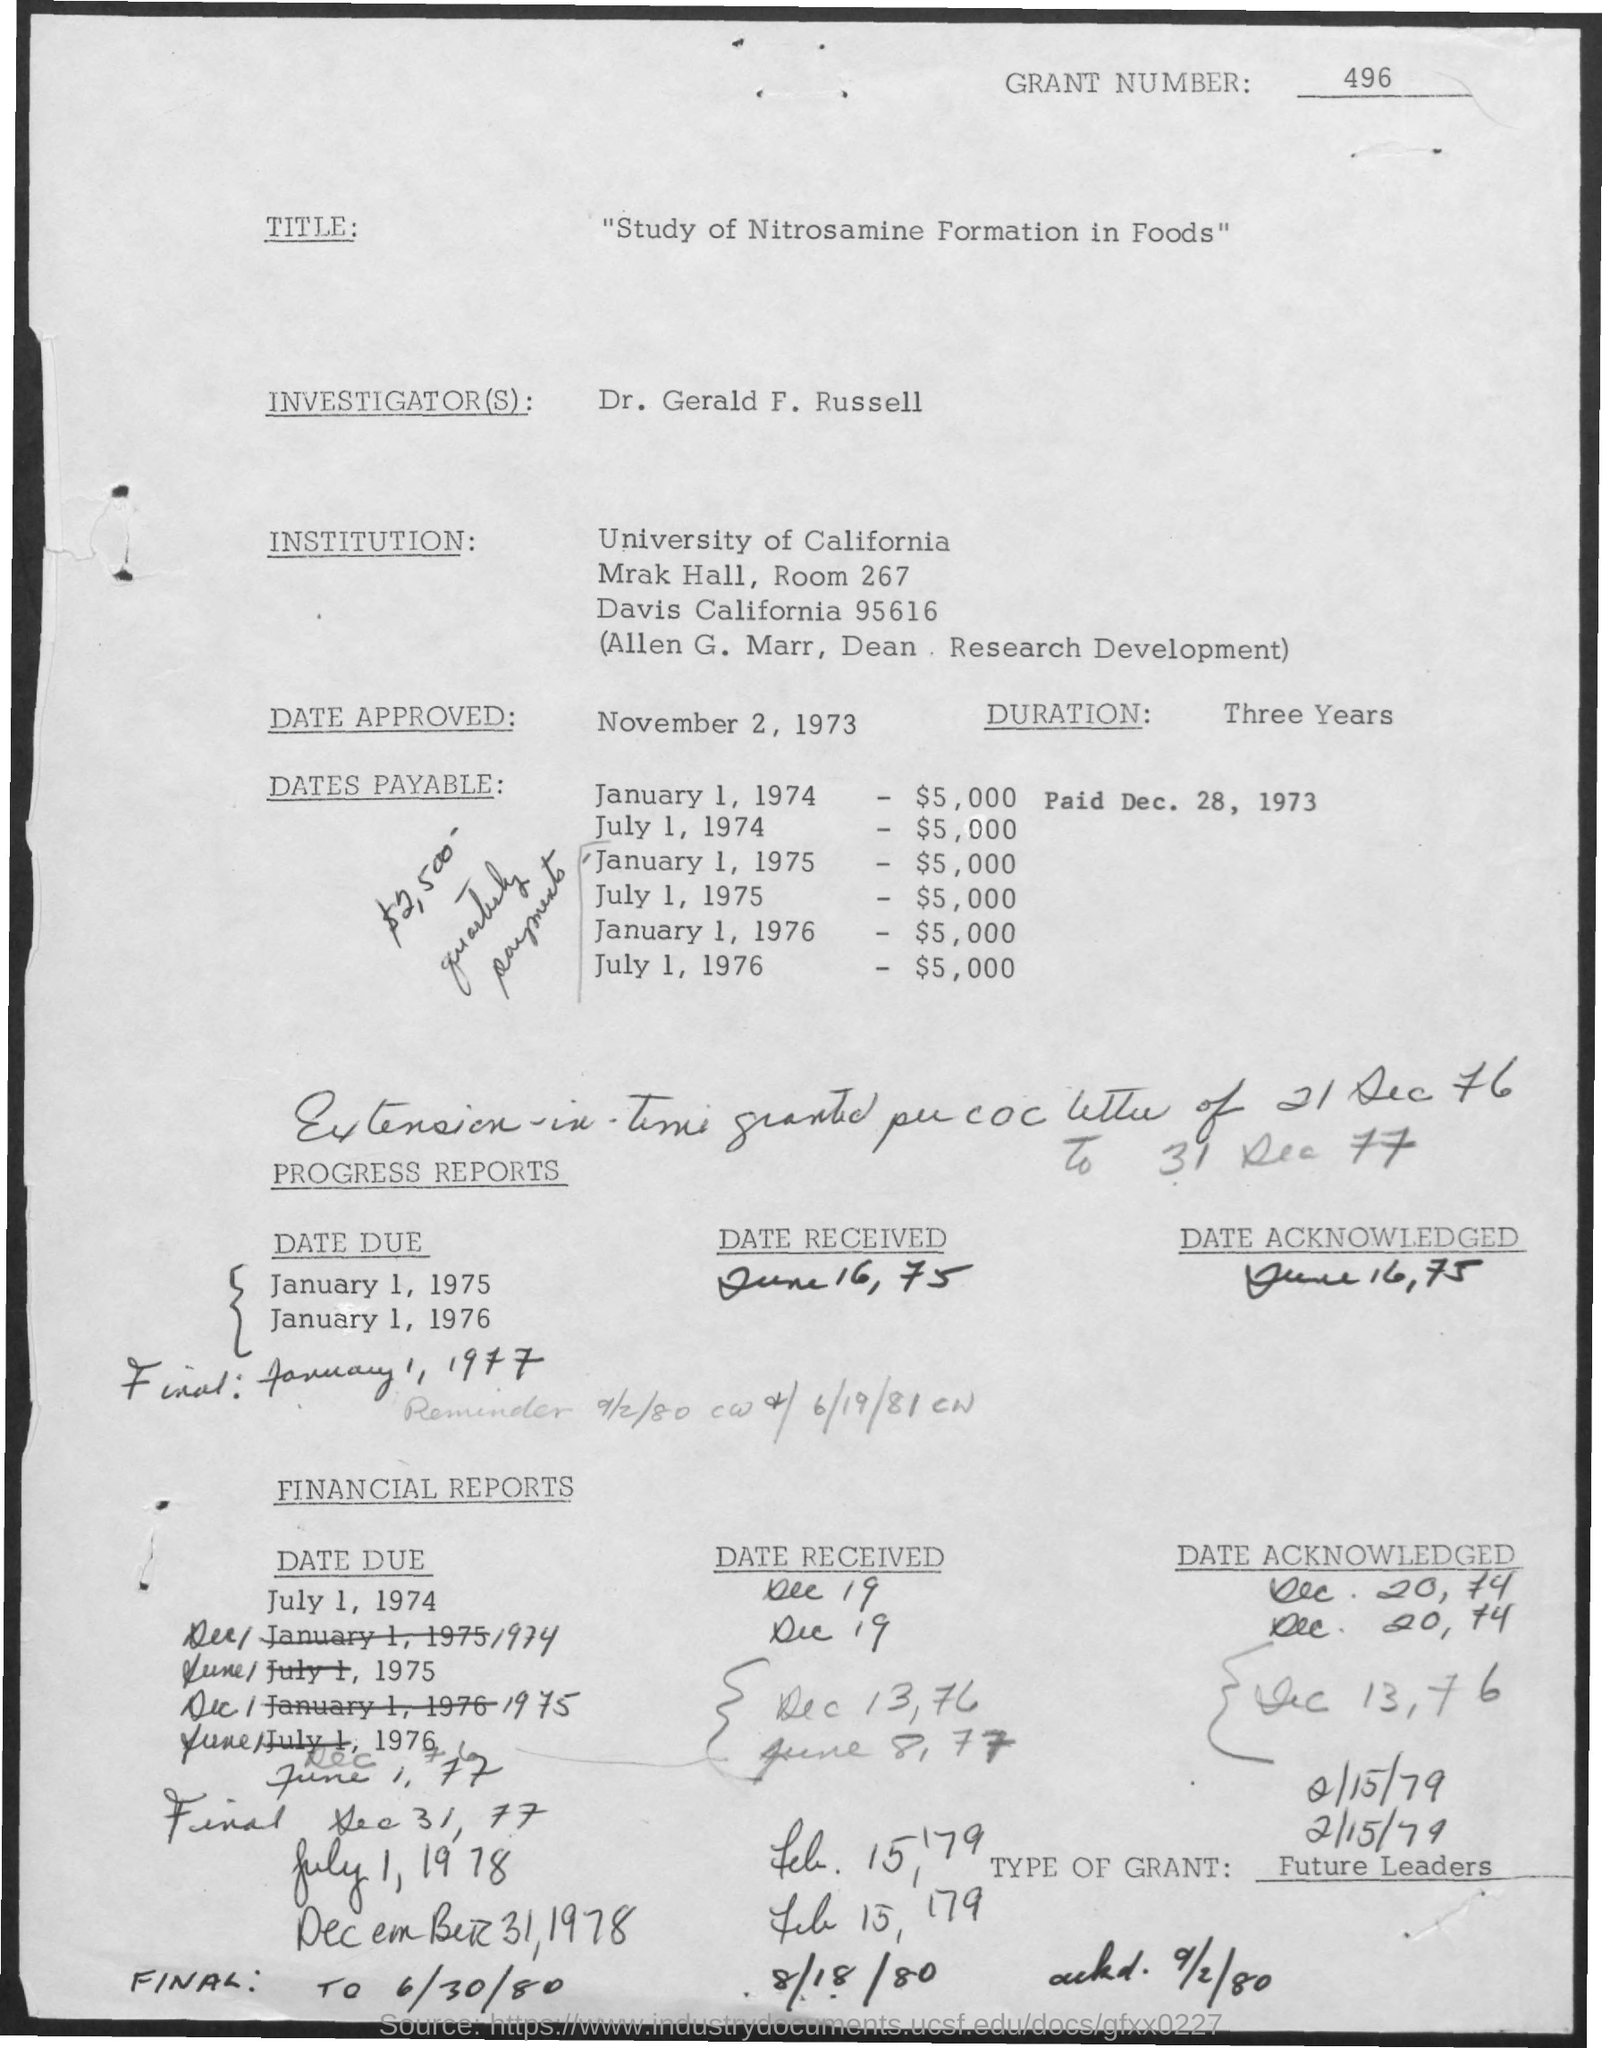What is the grant number mentioned in the given document?
Your answer should be compact. 496. What is the title mentioned in the given document?
Give a very brief answer. "study of Nitrosamine formation in foods". Who is the investigator mentioned in the document?
Ensure brevity in your answer.  Dr. Gerald F. Russell. Which university is mentioned in the document?
Ensure brevity in your answer.  University of California. What is the approved date mentioned in the document?
Ensure brevity in your answer.  November 2, 1973. 